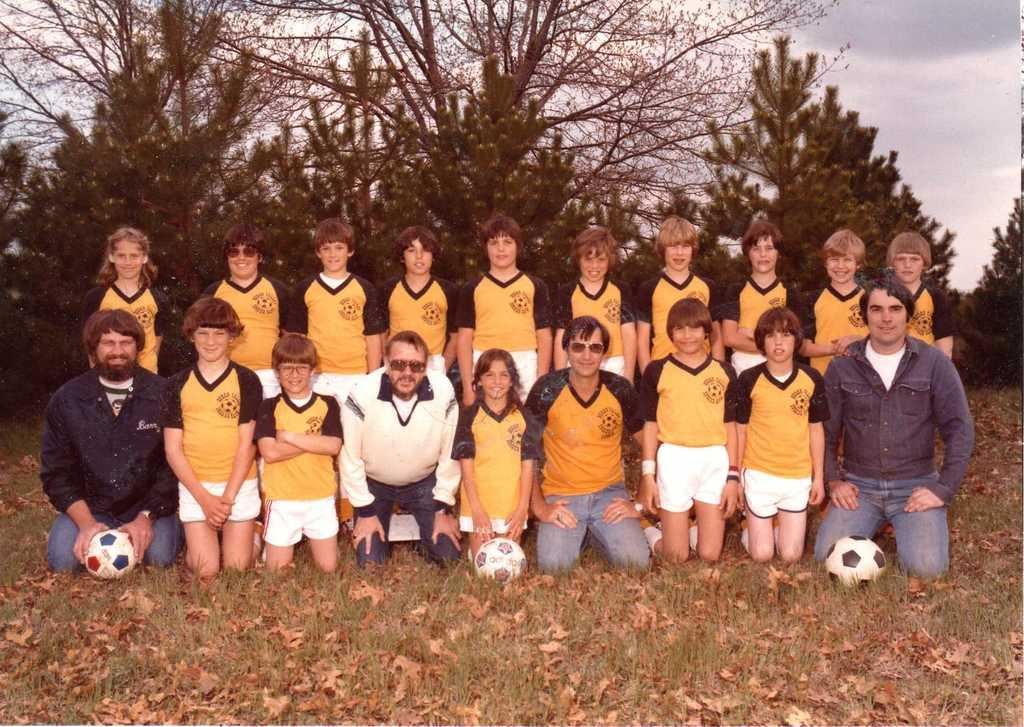What is the main subject of the image? The main subject of the image is a team of people. Where are the team members located in the image? The team members are sitting on the grass in the image. What objects can be seen in the image besides the team members? There are three balls visible in the image. What can be seen in the background of the image? There are trees visible in the background of the image. What type of mine can be seen in the image? There is no mine present in the image; it features a team of people sitting on the grass with three balls. What kind of bait is being used by the team in the image? There is no bait or fishing activity depicted in the image; it shows a team sitting on the grass with balls. 